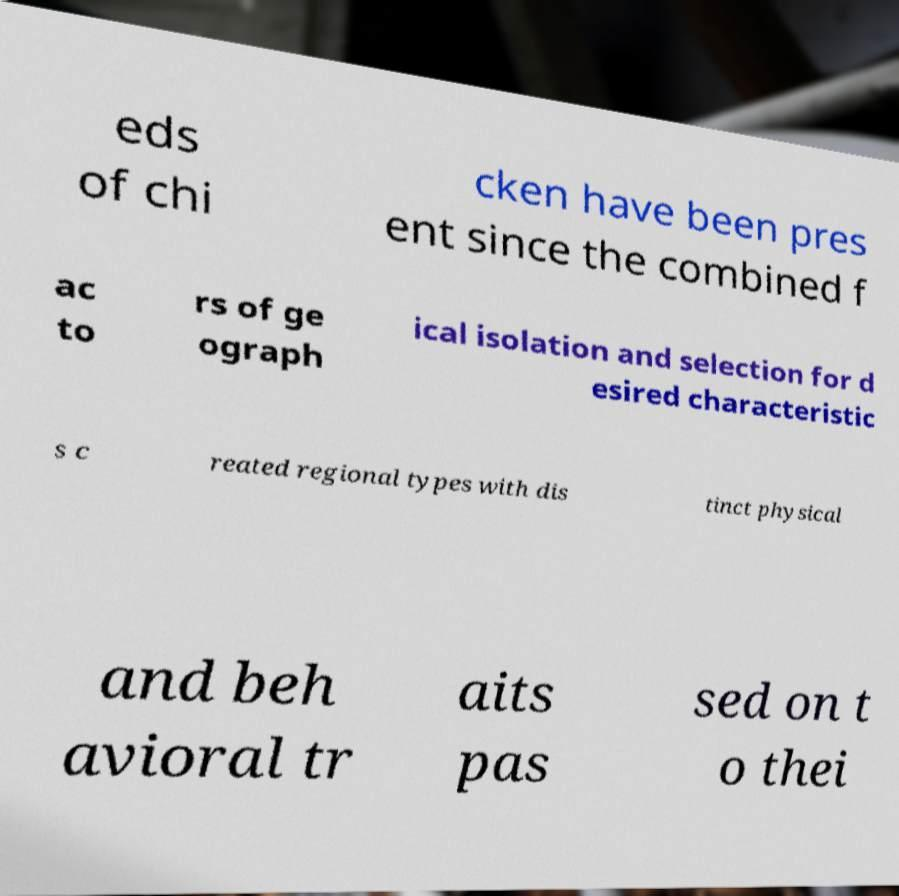What messages or text are displayed in this image? I need them in a readable, typed format. eds of chi cken have been pres ent since the combined f ac to rs of ge ograph ical isolation and selection for d esired characteristic s c reated regional types with dis tinct physical and beh avioral tr aits pas sed on t o thei 